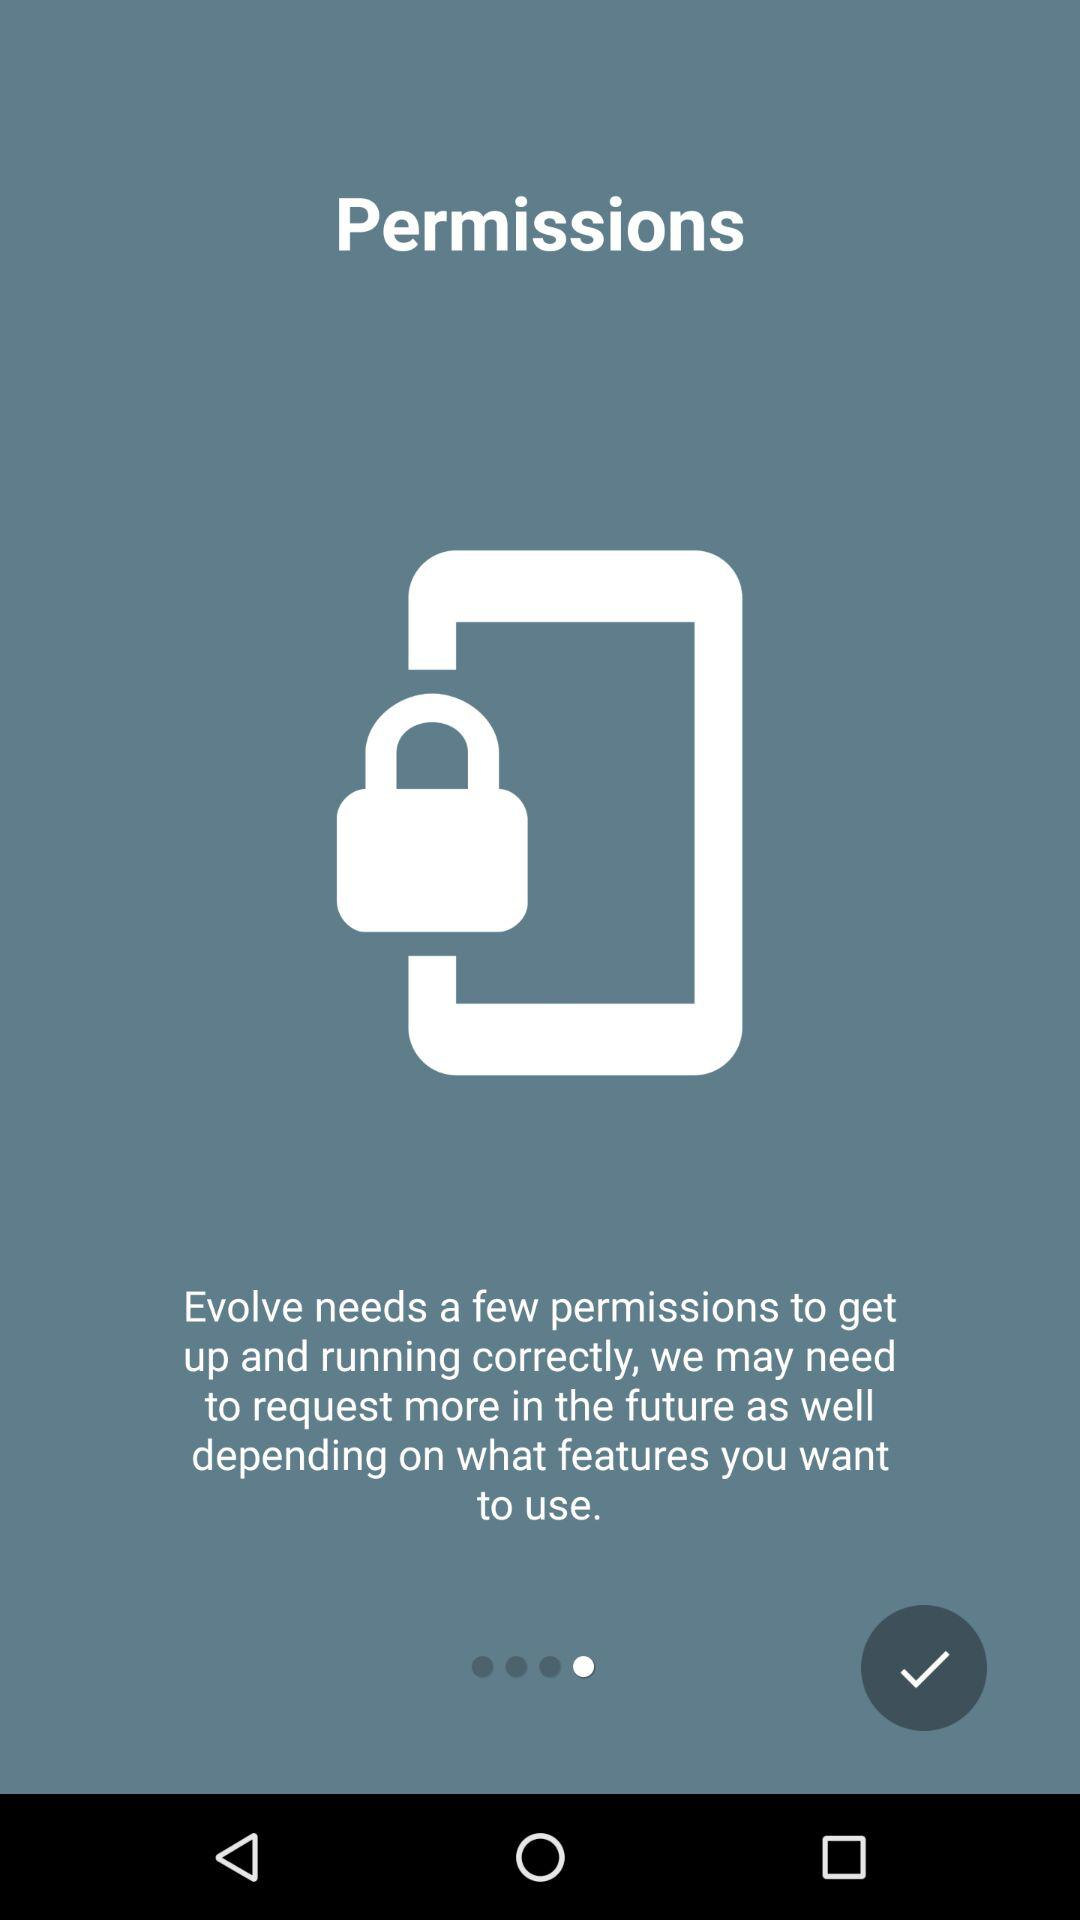What application is asking for permission? The application asking for permission is "Evolve". 